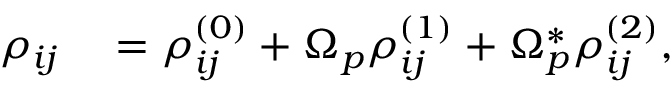Convert formula to latex. <formula><loc_0><loc_0><loc_500><loc_500>\begin{array} { r l } { \rho _ { i j } } & = \rho _ { i j } ^ { ( 0 ) } + \Omega _ { p } \rho _ { i j } ^ { ( 1 ) } + \Omega _ { p } ^ { * } \rho _ { i j } ^ { ( 2 ) } , } \end{array}</formula> 